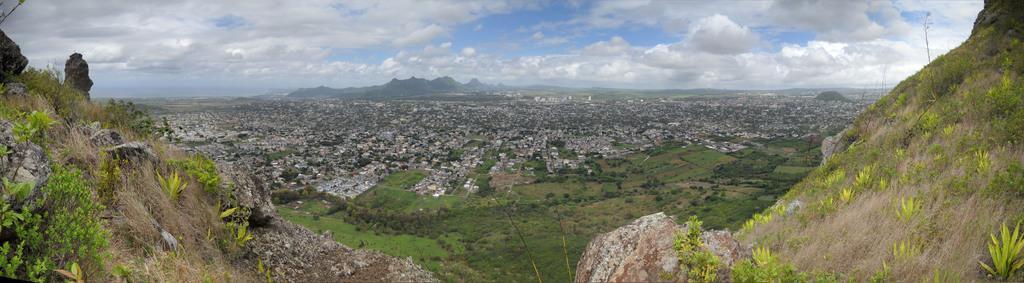Could you give a brief overview of what you see in this image? There are mountains in the foreground area of the image, there are buildings and greenery in the center. There are mountains and the sky in the background. 